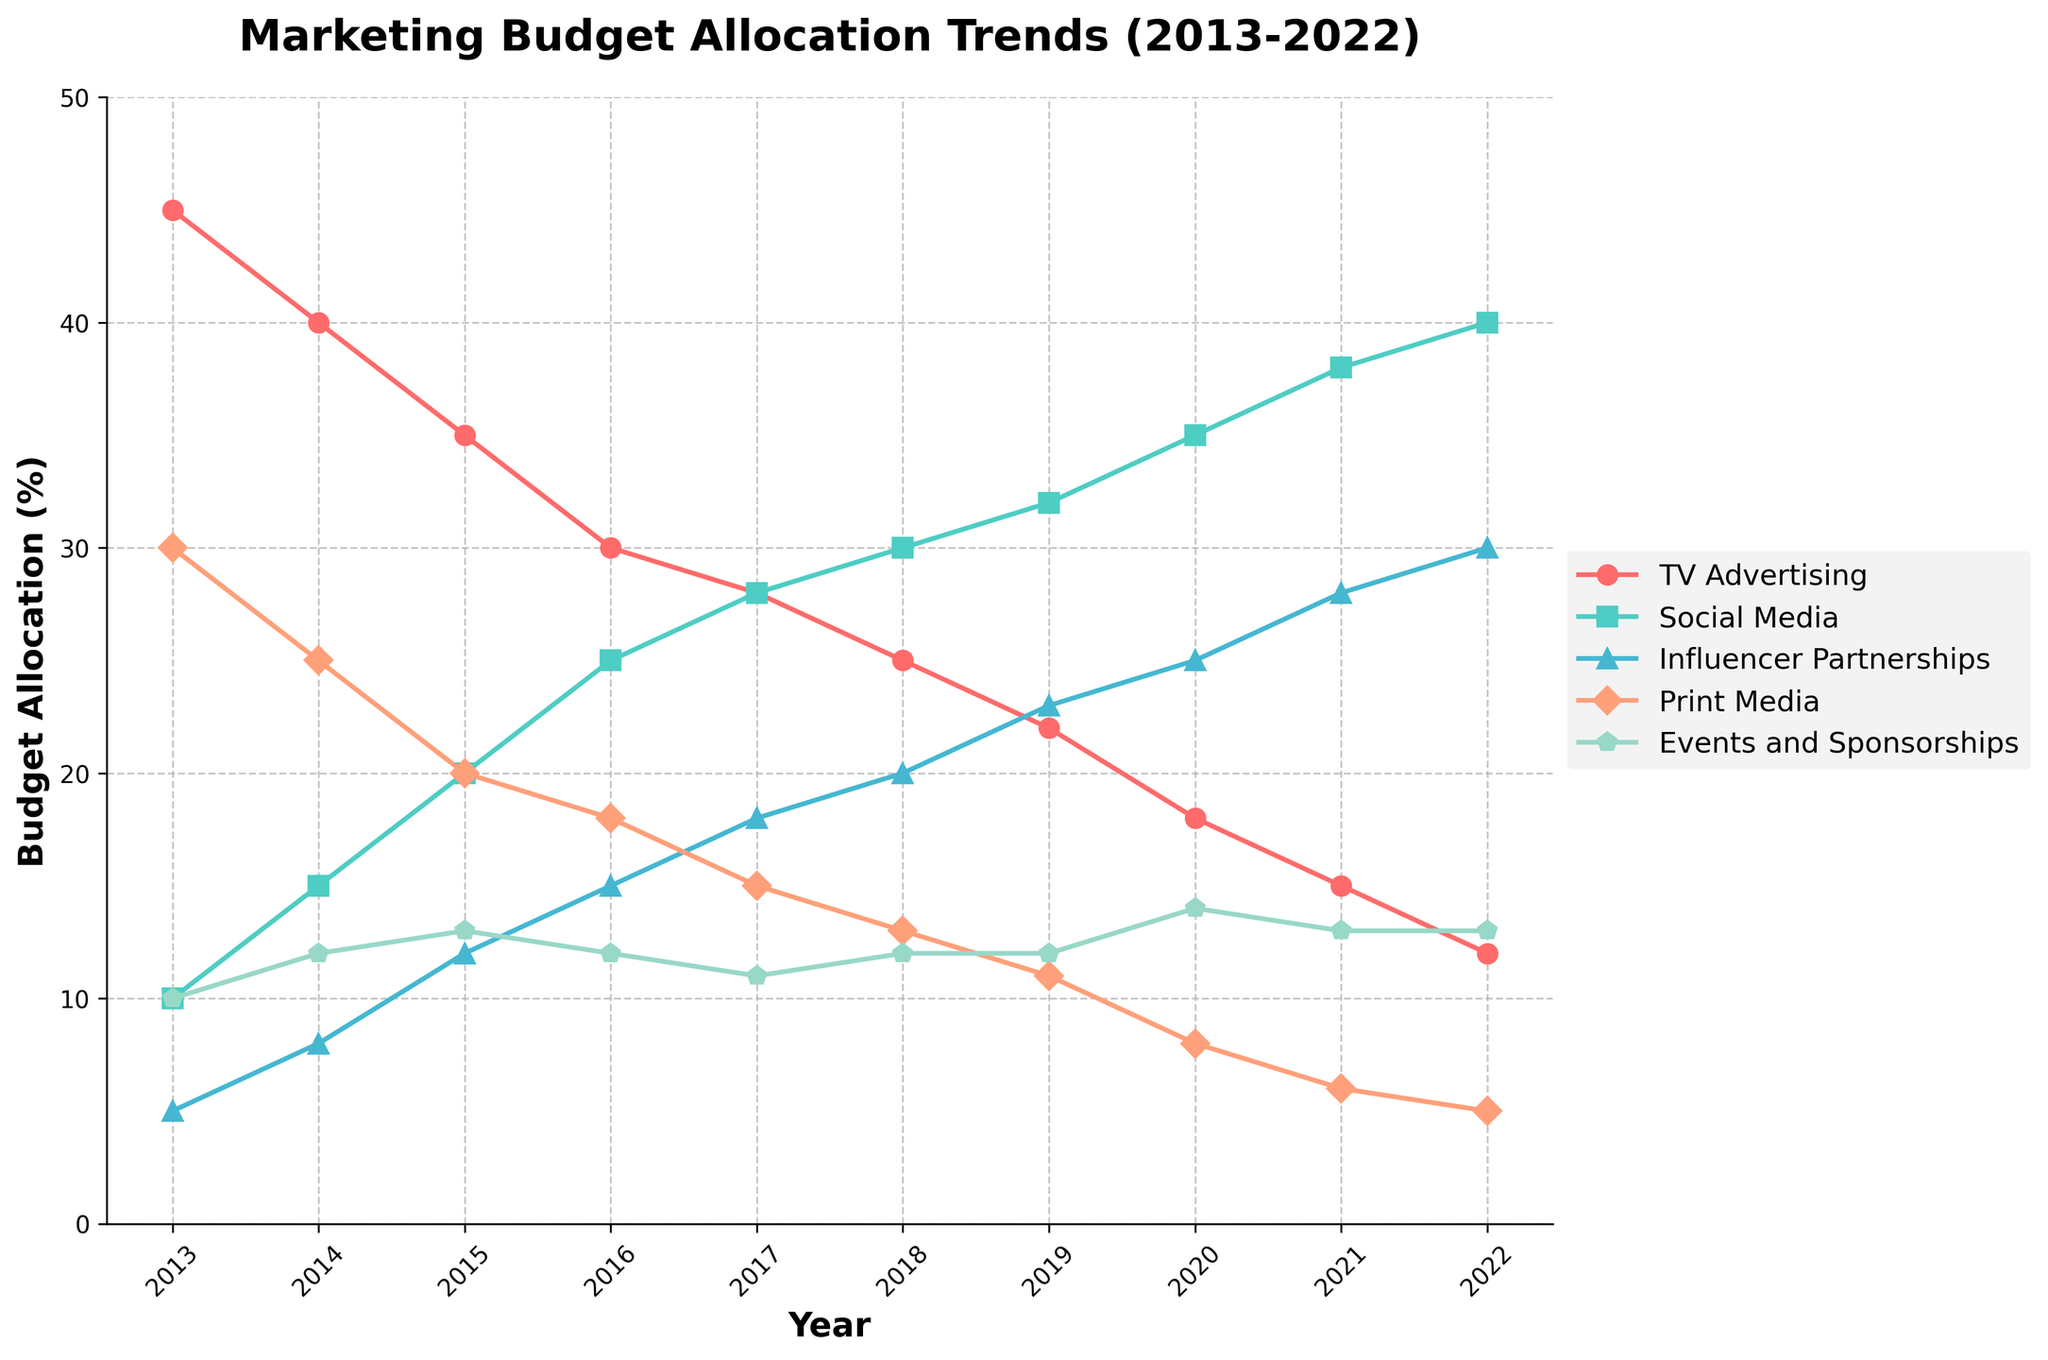What is the trend of the budget allocation for TV Advertising from 2013 to 2022? To determine the trend, observe the line representing TV Advertising. The line starts at a high point in 2013 and consistently decreases until 2022.
Answer: Decreasing Which year saw the highest budget allocation for Social Media? To identify the year with the highest budget for Social Media, find the peak point on the Social Media line. The highest point occurs in 2022.
Answer: 2022 How does the budget allocation for Influencer Partnerships in 2016 compare to that in 2021? Find the points for Influencer Partnerships in 2016 and 2021 on the graph. In 2016, the budget was 15%, and in 2021, it increased to 28%. This indicates a significant rise.
Answer: Higher in 2021 Which channel had the most stable budget allocation over the decade? To find the most stable channel, identify the line with the least variation. The Events and Sponsorships line shows little fluctuation compared to others.
Answer: Events and Sponsorships What is the difference in budget allocation between Social Media and TV Advertising in the year 2015? Locate the budget allocations for Social Media and TV Advertising in 2015. Social Media is at 20%, and TV Advertising is at 35%. The difference is 35% - 20% = 15%.
Answer: 15% How did the allocation for Print Media change from 2018 to 2020? Observe the Print Media line between 2018 and 2020. It starts at 13% in 2018 and drops to 8% in 2020. This signifies a reduction.
Answer: Decreased Which year had the lowest budget allocation for Print Media? Find the lowest point on the Print Media line. The lowest point is in 2022, where the allocation is 5%.
Answer: 2022 What is the average budget allocation for Events and Sponsorships over the decade? Sum the annual allocations for Events and Sponsorships: (10 + 12 + 13 + 12 + 11 + 12 + 12 + 14 + 13 + 13) = 122. Divide this sum by 10 (number of years) to get the average: 122 / 10 = 12.2%.
Answer: 12.2% Is there any channel that consistently increased its budget allocation every year? Check if any line consistently rises each year. The Social Media line consistently increases every year from 2013 to 2022.
Answer: Social Media Compare the budget allocation between Influencer Partnerships and Events and Sponsorships in 2020. Which one had a higher budget and by how much? Locate the budget for Influencer Partnerships (25%) and Events and Sponsorships (14%) in 2020. Subtract the Events and Sponsorships budget from the Influencer Partnerships budget: 25% - 14% = 11%. Influencer Partnerships had a higher budget.
Answer: Influencer Partnerships by 11% 